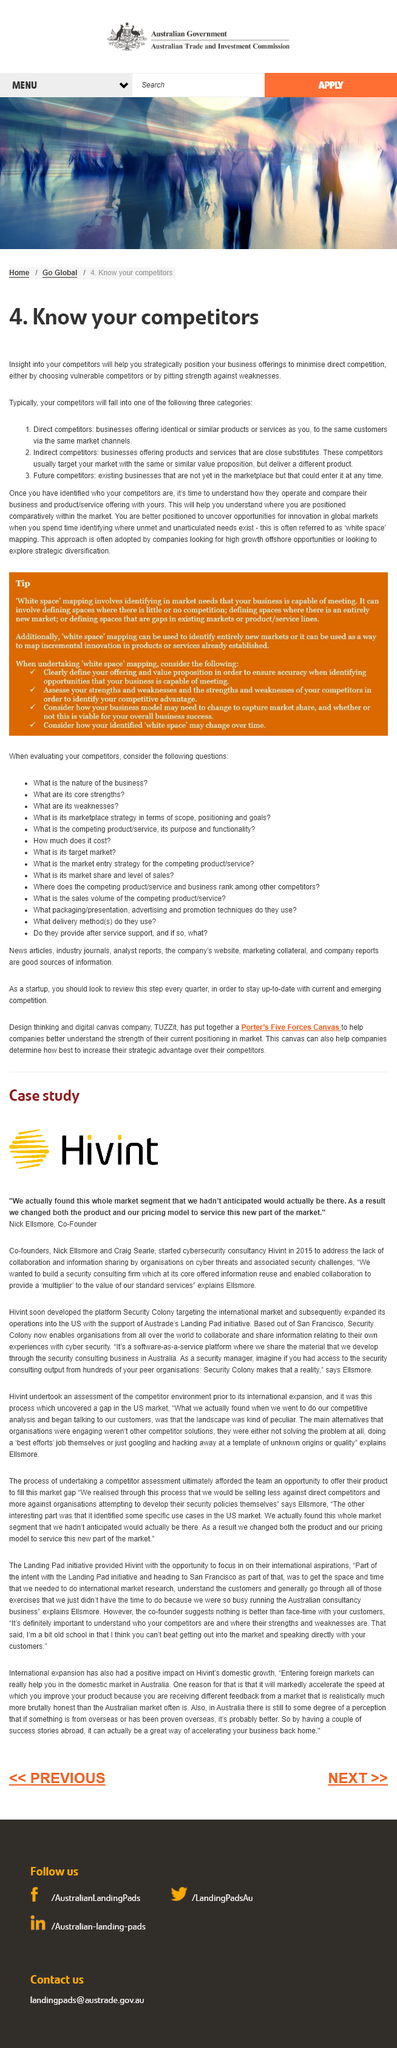Highlight a few significant elements in this photo. Indirect competitors are businesses that offer products or services that are similar but not exact substitutes to a company's offerings. The three categories in which competitors can be placed are Direct competitors, Indirect competitors, and Future competitors. Your competitors will typically fall into three categories, which means that they will be categorized as low-cost providers, differentiated providers, or market leaders. 